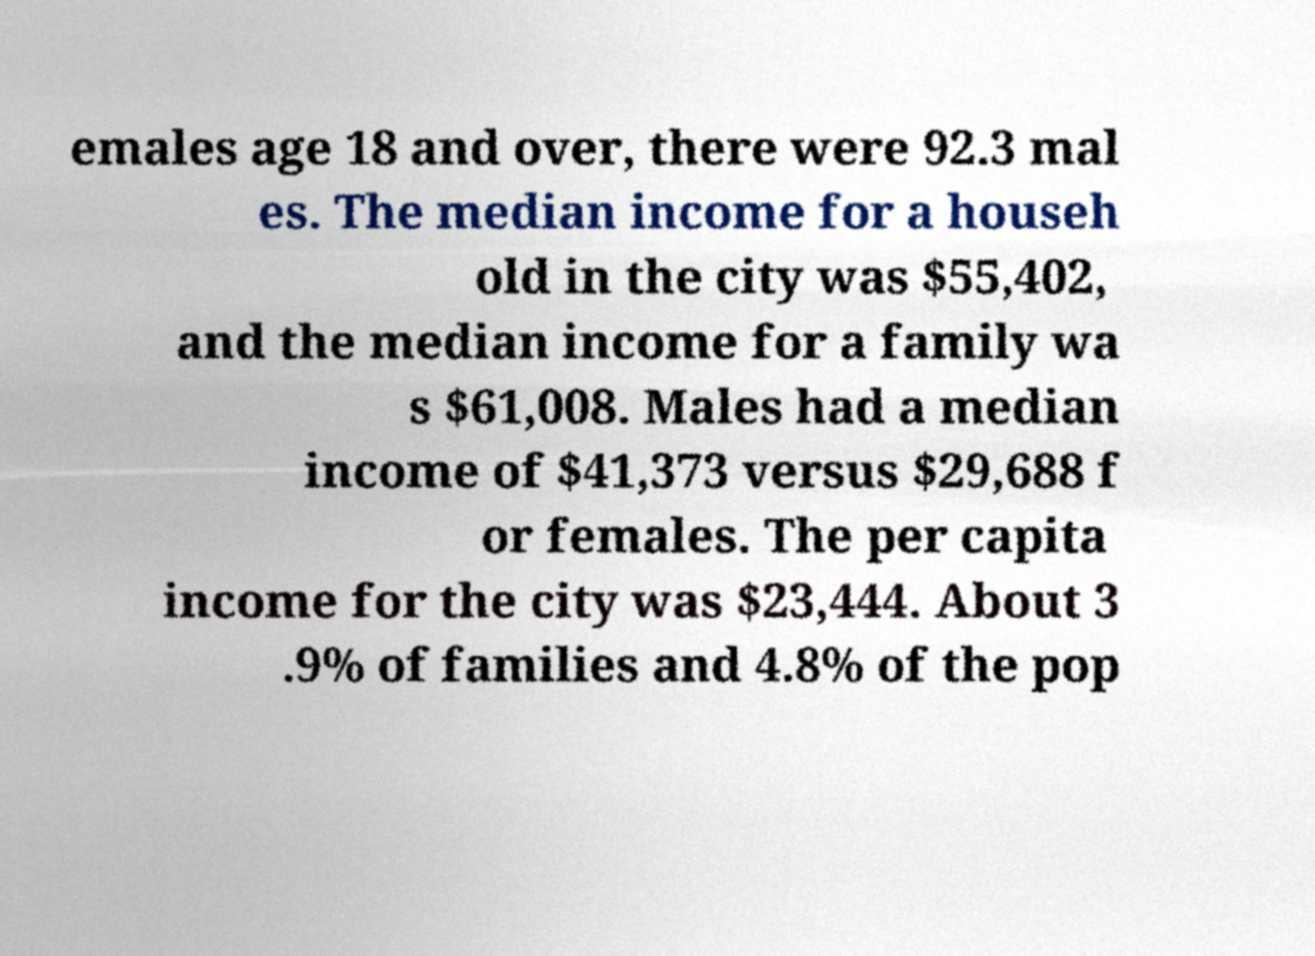Please read and relay the text visible in this image. What does it say? emales age 18 and over, there were 92.3 mal es. The median income for a househ old in the city was $55,402, and the median income for a family wa s $61,008. Males had a median income of $41,373 versus $29,688 f or females. The per capita income for the city was $23,444. About 3 .9% of families and 4.8% of the pop 